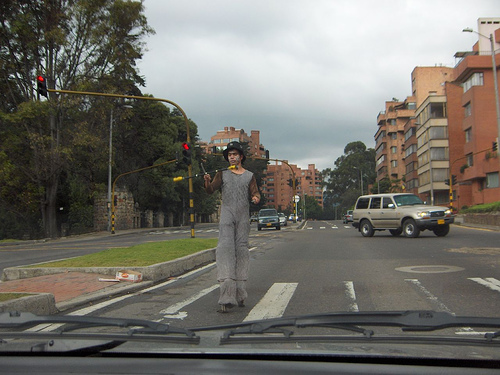<image>What is driving lots of people? I am not sure what is driving lots of people. It can be a car or an SUV. What is driving lots of people? I am not sure what is driving lots of people. It can be seen that 'guy on stilts' or 'car' is driving them. 